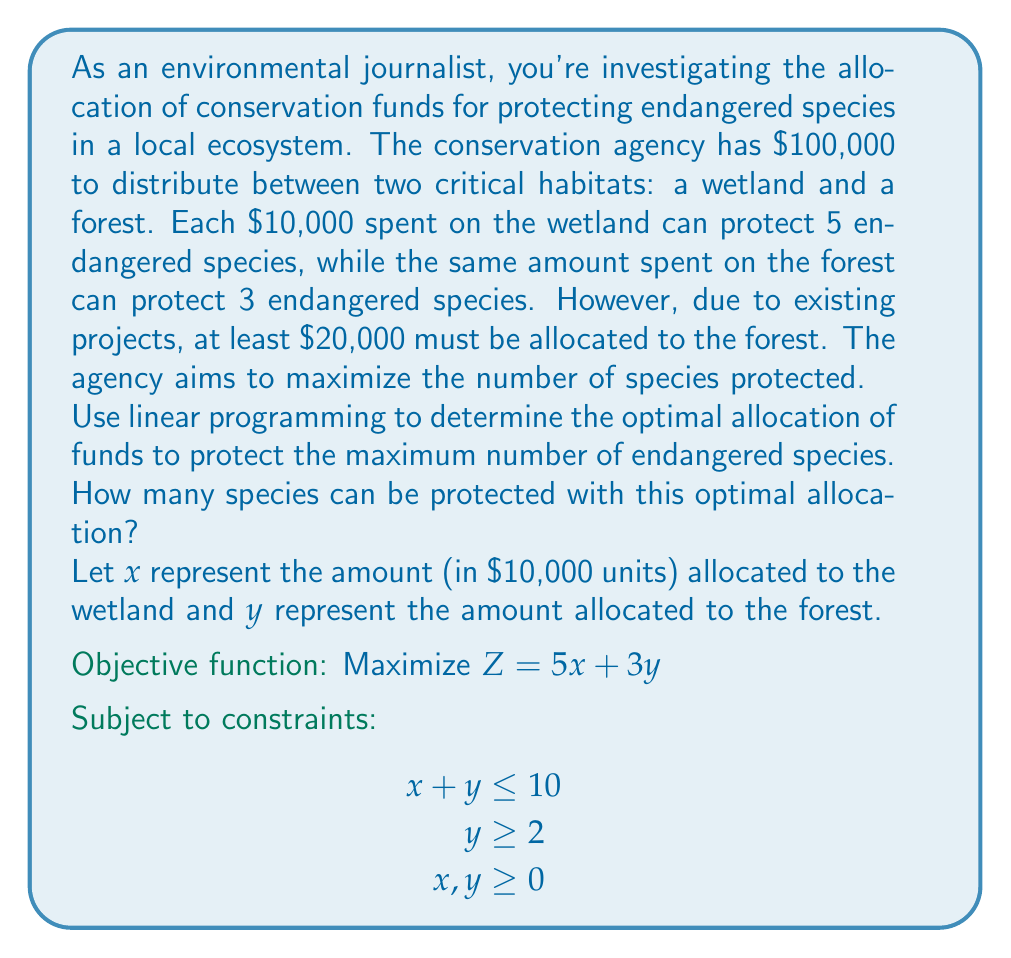Can you solve this math problem? To solve this linear programming problem, we'll follow these steps:

1) Identify the corner points of the feasible region:
   The feasible region is bounded by the constraints $x + y = 10$, $y = 2$, and the axes.
   Corner points are: (0, 2), (8, 2), and (0, 10)

2) Evaluate the objective function at each corner point:
   At (0, 2): $Z = 5(0) + 3(2) = 6$
   At (8, 2): $Z = 5(8) + 3(2) = 46$
   At (0, 10): $Z = 5(0) + 3(10) = 30$

3) The maximum value occurs at (8, 2), so this is the optimal solution.

4) Interpret the solution:
   $x = 8$ means $80,000 is allocated to the wetland
   $y = 2$ means $20,000 is allocated to the forest

5) Calculate the number of species protected:
   Wetland: $5 * 8 = 40$ species
   Forest: $3 * 2 = 6$ species
   Total: $40 + 6 = 46$ species

Therefore, the optimal allocation protects 46 endangered species.
Answer: 46 species 